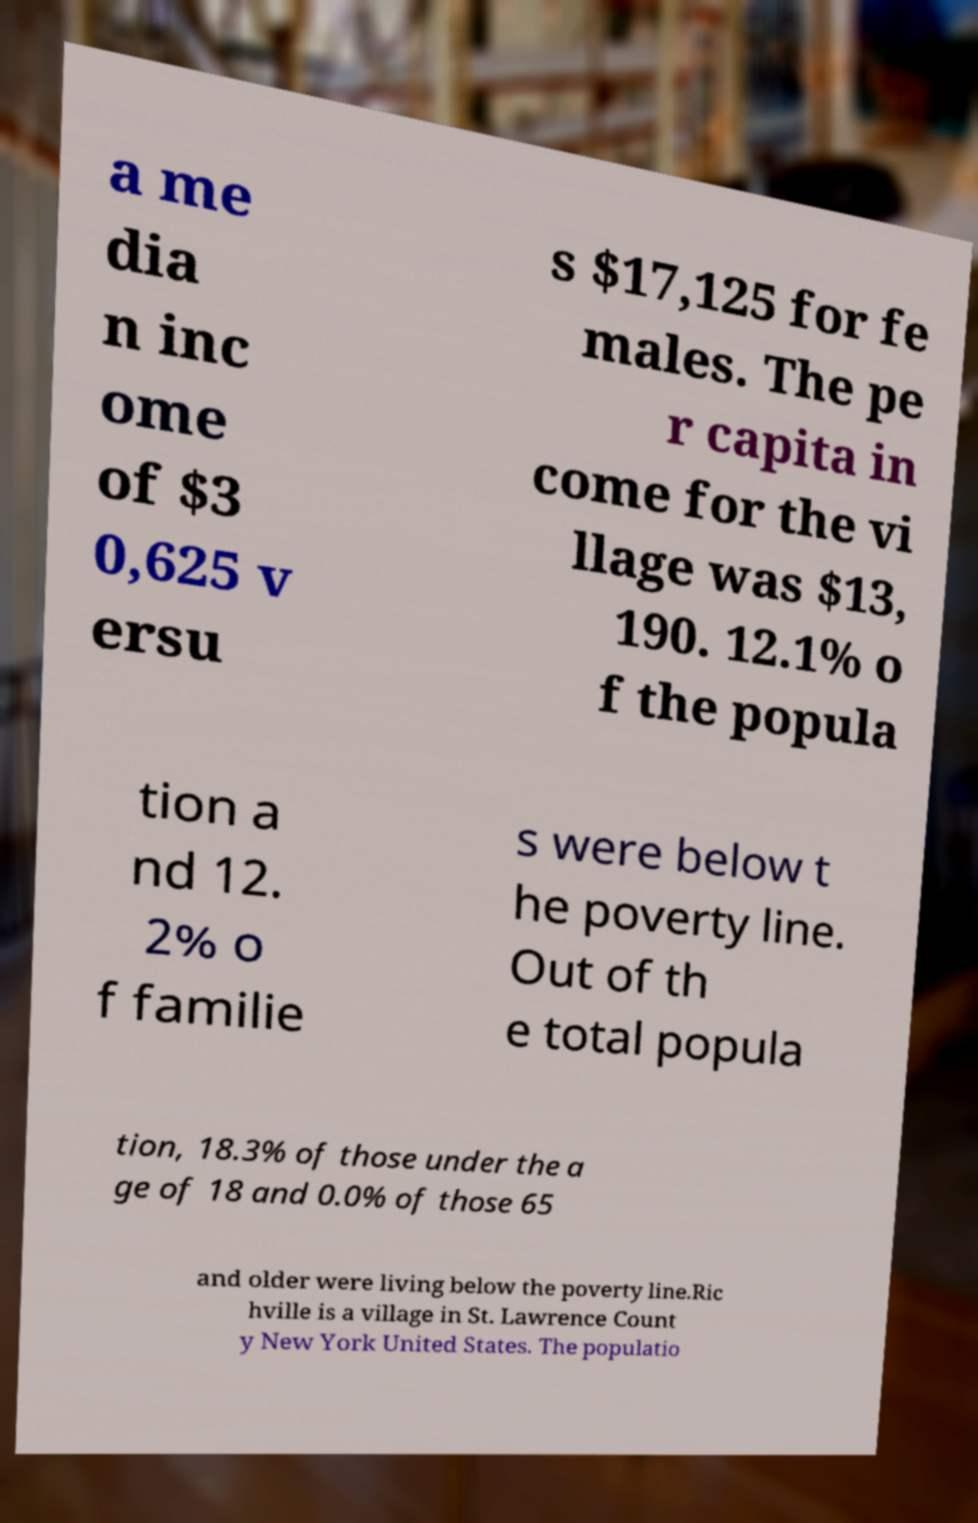I need the written content from this picture converted into text. Can you do that? a me dia n inc ome of $3 0,625 v ersu s $17,125 for fe males. The pe r capita in come for the vi llage was $13, 190. 12.1% o f the popula tion a nd 12. 2% o f familie s were below t he poverty line. Out of th e total popula tion, 18.3% of those under the a ge of 18 and 0.0% of those 65 and older were living below the poverty line.Ric hville is a village in St. Lawrence Count y New York United States. The populatio 